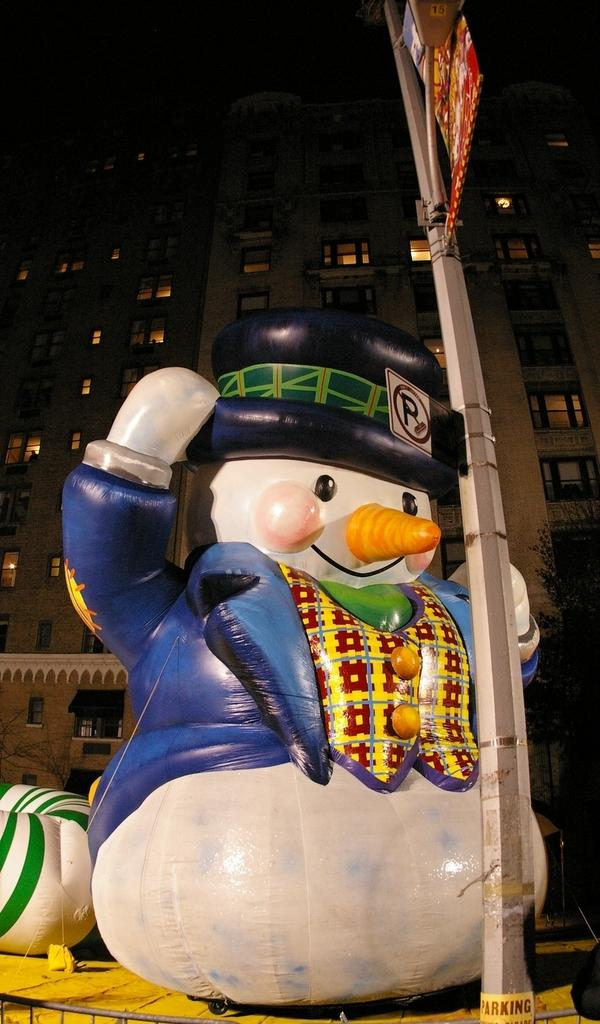What type of toy is visible in the image? There is a balloon toy in the image. Where is the balloon toy placed? The balloon toy is placed on a wooden bench. What is in front of the bench? There is a pole in front of the bench. What can be seen in the background of the image? There is a building in the background of the image. What feature of the building is mentioned in the facts? The building has windows. How does the rainstorm affect the balloon toy in the image? There is no rainstorm present in the image, so it cannot affect the balloon toy. 